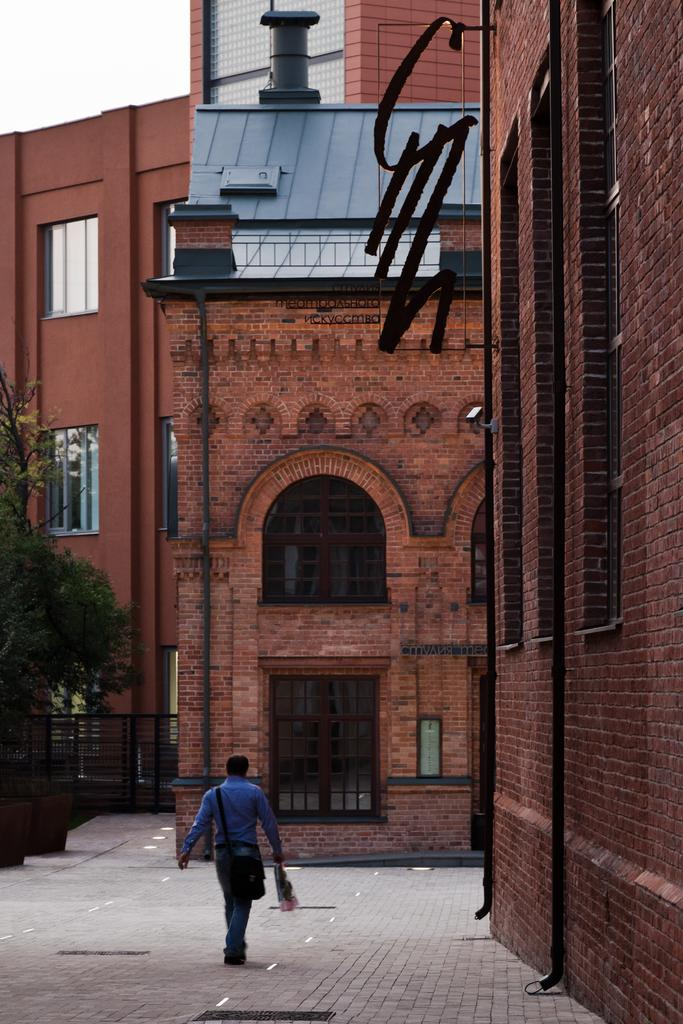What is the man in the image holding? The man is holding a handbag and an object in his hand. What can be seen in the background of the image? There are buildings, trees, and pipes attached to the building in the image. What type of structure is present in the image? There is an iron railing in the image. How many babies are in jail in the image? There are no babies or jails present in the image. 